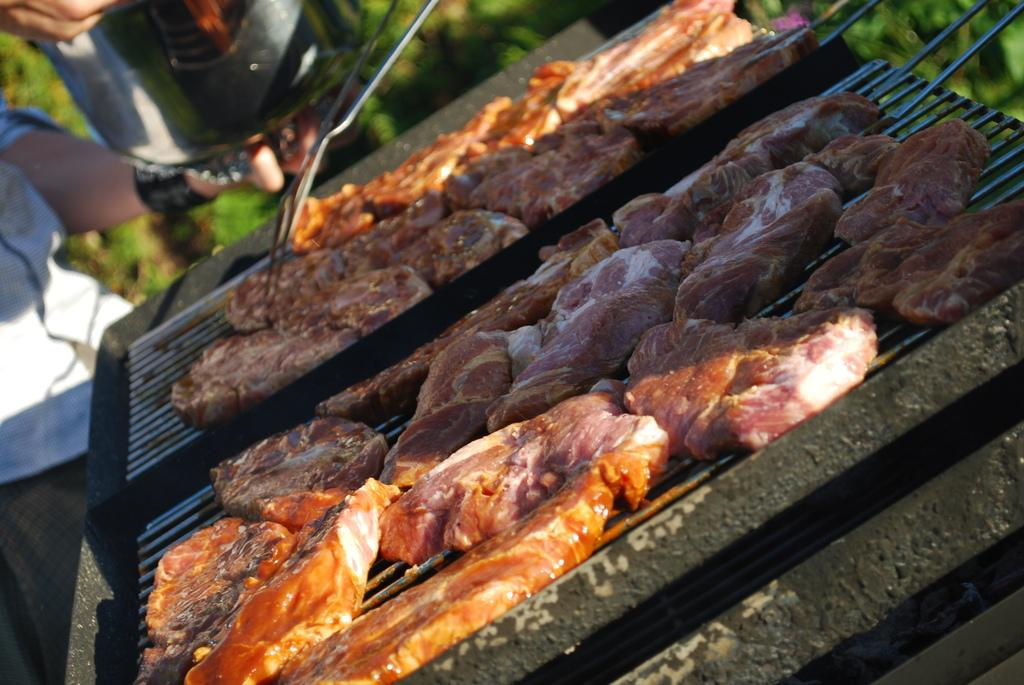What is being cooked on the grill in the image? There are pieces of meat on the grill in the image. What is the person on the left side of the image doing? The person is holding an object in the image. What can be seen in the background of the image? There are plants visible in the background of the image. What is the name of the person holding the object in the image? The image does not provide any information about the person's name. 